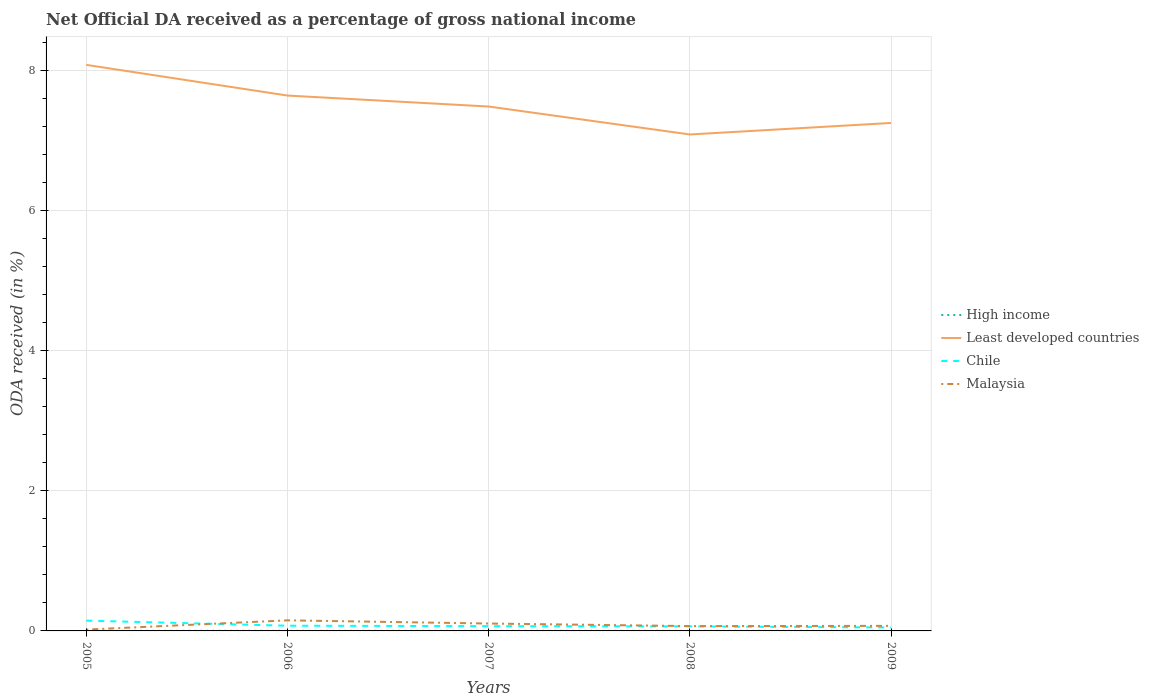How many different coloured lines are there?
Give a very brief answer. 4. Does the line corresponding to High income intersect with the line corresponding to Malaysia?
Offer a terse response. No. Across all years, what is the maximum net official DA received in High income?
Make the answer very short. 0. What is the total net official DA received in Malaysia in the graph?
Offer a very short reply. 0.08. What is the difference between the highest and the second highest net official DA received in High income?
Your answer should be very brief. 0. Is the net official DA received in High income strictly greater than the net official DA received in Malaysia over the years?
Keep it short and to the point. Yes. Are the values on the major ticks of Y-axis written in scientific E-notation?
Your answer should be compact. No. What is the title of the graph?
Provide a succinct answer. Net Official DA received as a percentage of gross national income. What is the label or title of the Y-axis?
Your response must be concise. ODA received (in %). What is the ODA received (in %) in High income in 2005?
Your answer should be very brief. 0. What is the ODA received (in %) in Least developed countries in 2005?
Provide a short and direct response. 8.08. What is the ODA received (in %) of Chile in 2005?
Your response must be concise. 0.15. What is the ODA received (in %) in Malaysia in 2005?
Give a very brief answer. 0.02. What is the ODA received (in %) in High income in 2006?
Provide a short and direct response. 0. What is the ODA received (in %) of Least developed countries in 2006?
Offer a very short reply. 7.64. What is the ODA received (in %) of Chile in 2006?
Your answer should be compact. 0.07. What is the ODA received (in %) of Malaysia in 2006?
Your response must be concise. 0.15. What is the ODA received (in %) in High income in 2007?
Provide a succinct answer. 0. What is the ODA received (in %) of Least developed countries in 2007?
Offer a terse response. 7.49. What is the ODA received (in %) in Chile in 2007?
Keep it short and to the point. 0.07. What is the ODA received (in %) of Malaysia in 2007?
Ensure brevity in your answer.  0.11. What is the ODA received (in %) of High income in 2008?
Provide a succinct answer. 0. What is the ODA received (in %) of Least developed countries in 2008?
Your response must be concise. 7.09. What is the ODA received (in %) in Chile in 2008?
Give a very brief answer. 0.06. What is the ODA received (in %) in Malaysia in 2008?
Give a very brief answer. 0.07. What is the ODA received (in %) of High income in 2009?
Give a very brief answer. 0. What is the ODA received (in %) in Least developed countries in 2009?
Offer a very short reply. 7.25. What is the ODA received (in %) in Chile in 2009?
Make the answer very short. 0.05. What is the ODA received (in %) of Malaysia in 2009?
Ensure brevity in your answer.  0.07. Across all years, what is the maximum ODA received (in %) in High income?
Your answer should be compact. 0. Across all years, what is the maximum ODA received (in %) of Least developed countries?
Offer a very short reply. 8.08. Across all years, what is the maximum ODA received (in %) of Chile?
Keep it short and to the point. 0.15. Across all years, what is the maximum ODA received (in %) in Malaysia?
Give a very brief answer. 0.15. Across all years, what is the minimum ODA received (in %) of High income?
Give a very brief answer. 0. Across all years, what is the minimum ODA received (in %) of Least developed countries?
Your answer should be very brief. 7.09. Across all years, what is the minimum ODA received (in %) in Chile?
Ensure brevity in your answer.  0.05. Across all years, what is the minimum ODA received (in %) in Malaysia?
Your answer should be very brief. 0.02. What is the total ODA received (in %) in High income in the graph?
Offer a very short reply. 0.01. What is the total ODA received (in %) of Least developed countries in the graph?
Your response must be concise. 37.56. What is the total ODA received (in %) of Chile in the graph?
Ensure brevity in your answer.  0.4. What is the total ODA received (in %) of Malaysia in the graph?
Your response must be concise. 0.42. What is the difference between the ODA received (in %) of High income in 2005 and that in 2006?
Give a very brief answer. -0. What is the difference between the ODA received (in %) in Least developed countries in 2005 and that in 2006?
Provide a short and direct response. 0.44. What is the difference between the ODA received (in %) in Chile in 2005 and that in 2006?
Offer a terse response. 0.07. What is the difference between the ODA received (in %) of Malaysia in 2005 and that in 2006?
Provide a short and direct response. -0.13. What is the difference between the ODA received (in %) of High income in 2005 and that in 2007?
Keep it short and to the point. -0. What is the difference between the ODA received (in %) of Least developed countries in 2005 and that in 2007?
Give a very brief answer. 0.59. What is the difference between the ODA received (in %) in Chile in 2005 and that in 2007?
Offer a very short reply. 0.08. What is the difference between the ODA received (in %) in Malaysia in 2005 and that in 2007?
Offer a very short reply. -0.09. What is the difference between the ODA received (in %) of High income in 2005 and that in 2008?
Your answer should be compact. -0. What is the difference between the ODA received (in %) in Least developed countries in 2005 and that in 2008?
Your answer should be very brief. 0.99. What is the difference between the ODA received (in %) of Chile in 2005 and that in 2008?
Your answer should be very brief. 0.08. What is the difference between the ODA received (in %) of Malaysia in 2005 and that in 2008?
Keep it short and to the point. -0.05. What is the difference between the ODA received (in %) of High income in 2005 and that in 2009?
Offer a very short reply. -0. What is the difference between the ODA received (in %) of Least developed countries in 2005 and that in 2009?
Ensure brevity in your answer.  0.83. What is the difference between the ODA received (in %) of Chile in 2005 and that in 2009?
Your answer should be very brief. 0.1. What is the difference between the ODA received (in %) of Malaysia in 2005 and that in 2009?
Offer a very short reply. -0.05. What is the difference between the ODA received (in %) of High income in 2006 and that in 2007?
Your answer should be compact. 0. What is the difference between the ODA received (in %) in Least developed countries in 2006 and that in 2007?
Provide a short and direct response. 0.16. What is the difference between the ODA received (in %) in Chile in 2006 and that in 2007?
Provide a short and direct response. 0.01. What is the difference between the ODA received (in %) of Malaysia in 2006 and that in 2007?
Provide a succinct answer. 0.05. What is the difference between the ODA received (in %) in High income in 2006 and that in 2008?
Your answer should be compact. -0. What is the difference between the ODA received (in %) of Least developed countries in 2006 and that in 2008?
Give a very brief answer. 0.56. What is the difference between the ODA received (in %) in Chile in 2006 and that in 2008?
Offer a very short reply. 0.01. What is the difference between the ODA received (in %) in Malaysia in 2006 and that in 2008?
Provide a short and direct response. 0.08. What is the difference between the ODA received (in %) of Least developed countries in 2006 and that in 2009?
Make the answer very short. 0.39. What is the difference between the ODA received (in %) in Chile in 2006 and that in 2009?
Provide a short and direct response. 0.03. What is the difference between the ODA received (in %) in Malaysia in 2006 and that in 2009?
Offer a very short reply. 0.08. What is the difference between the ODA received (in %) in High income in 2007 and that in 2008?
Give a very brief answer. -0. What is the difference between the ODA received (in %) of Least developed countries in 2007 and that in 2008?
Give a very brief answer. 0.4. What is the difference between the ODA received (in %) of Chile in 2007 and that in 2008?
Ensure brevity in your answer.  0. What is the difference between the ODA received (in %) of Malaysia in 2007 and that in 2008?
Give a very brief answer. 0.04. What is the difference between the ODA received (in %) in Least developed countries in 2007 and that in 2009?
Provide a short and direct response. 0.23. What is the difference between the ODA received (in %) in Chile in 2007 and that in 2009?
Your answer should be compact. 0.02. What is the difference between the ODA received (in %) in Malaysia in 2007 and that in 2009?
Ensure brevity in your answer.  0.03. What is the difference between the ODA received (in %) in Least developed countries in 2008 and that in 2009?
Ensure brevity in your answer.  -0.16. What is the difference between the ODA received (in %) of Chile in 2008 and that in 2009?
Your answer should be very brief. 0.02. What is the difference between the ODA received (in %) of Malaysia in 2008 and that in 2009?
Offer a very short reply. -0. What is the difference between the ODA received (in %) in High income in 2005 and the ODA received (in %) in Least developed countries in 2006?
Your answer should be very brief. -7.64. What is the difference between the ODA received (in %) in High income in 2005 and the ODA received (in %) in Chile in 2006?
Your answer should be very brief. -0.07. What is the difference between the ODA received (in %) in High income in 2005 and the ODA received (in %) in Malaysia in 2006?
Offer a terse response. -0.15. What is the difference between the ODA received (in %) of Least developed countries in 2005 and the ODA received (in %) of Chile in 2006?
Your answer should be compact. 8.01. What is the difference between the ODA received (in %) in Least developed countries in 2005 and the ODA received (in %) in Malaysia in 2006?
Give a very brief answer. 7.93. What is the difference between the ODA received (in %) in Chile in 2005 and the ODA received (in %) in Malaysia in 2006?
Provide a short and direct response. -0. What is the difference between the ODA received (in %) in High income in 2005 and the ODA received (in %) in Least developed countries in 2007?
Offer a very short reply. -7.49. What is the difference between the ODA received (in %) in High income in 2005 and the ODA received (in %) in Chile in 2007?
Your answer should be compact. -0.07. What is the difference between the ODA received (in %) in High income in 2005 and the ODA received (in %) in Malaysia in 2007?
Provide a short and direct response. -0.1. What is the difference between the ODA received (in %) in Least developed countries in 2005 and the ODA received (in %) in Chile in 2007?
Make the answer very short. 8.01. What is the difference between the ODA received (in %) of Least developed countries in 2005 and the ODA received (in %) of Malaysia in 2007?
Provide a short and direct response. 7.98. What is the difference between the ODA received (in %) in Chile in 2005 and the ODA received (in %) in Malaysia in 2007?
Offer a terse response. 0.04. What is the difference between the ODA received (in %) in High income in 2005 and the ODA received (in %) in Least developed countries in 2008?
Make the answer very short. -7.09. What is the difference between the ODA received (in %) of High income in 2005 and the ODA received (in %) of Chile in 2008?
Keep it short and to the point. -0.06. What is the difference between the ODA received (in %) in High income in 2005 and the ODA received (in %) in Malaysia in 2008?
Keep it short and to the point. -0.07. What is the difference between the ODA received (in %) of Least developed countries in 2005 and the ODA received (in %) of Chile in 2008?
Keep it short and to the point. 8.02. What is the difference between the ODA received (in %) of Least developed countries in 2005 and the ODA received (in %) of Malaysia in 2008?
Provide a short and direct response. 8.01. What is the difference between the ODA received (in %) of Chile in 2005 and the ODA received (in %) of Malaysia in 2008?
Make the answer very short. 0.08. What is the difference between the ODA received (in %) of High income in 2005 and the ODA received (in %) of Least developed countries in 2009?
Provide a succinct answer. -7.25. What is the difference between the ODA received (in %) in High income in 2005 and the ODA received (in %) in Chile in 2009?
Keep it short and to the point. -0.05. What is the difference between the ODA received (in %) in High income in 2005 and the ODA received (in %) in Malaysia in 2009?
Offer a terse response. -0.07. What is the difference between the ODA received (in %) of Least developed countries in 2005 and the ODA received (in %) of Chile in 2009?
Provide a short and direct response. 8.03. What is the difference between the ODA received (in %) of Least developed countries in 2005 and the ODA received (in %) of Malaysia in 2009?
Your answer should be very brief. 8.01. What is the difference between the ODA received (in %) in Chile in 2005 and the ODA received (in %) in Malaysia in 2009?
Keep it short and to the point. 0.07. What is the difference between the ODA received (in %) of High income in 2006 and the ODA received (in %) of Least developed countries in 2007?
Your answer should be compact. -7.49. What is the difference between the ODA received (in %) of High income in 2006 and the ODA received (in %) of Chile in 2007?
Your answer should be compact. -0.07. What is the difference between the ODA received (in %) in High income in 2006 and the ODA received (in %) in Malaysia in 2007?
Your answer should be very brief. -0.1. What is the difference between the ODA received (in %) of Least developed countries in 2006 and the ODA received (in %) of Chile in 2007?
Your response must be concise. 7.58. What is the difference between the ODA received (in %) in Least developed countries in 2006 and the ODA received (in %) in Malaysia in 2007?
Your answer should be very brief. 7.54. What is the difference between the ODA received (in %) in Chile in 2006 and the ODA received (in %) in Malaysia in 2007?
Provide a succinct answer. -0.03. What is the difference between the ODA received (in %) of High income in 2006 and the ODA received (in %) of Least developed countries in 2008?
Offer a terse response. -7.09. What is the difference between the ODA received (in %) of High income in 2006 and the ODA received (in %) of Chile in 2008?
Make the answer very short. -0.06. What is the difference between the ODA received (in %) of High income in 2006 and the ODA received (in %) of Malaysia in 2008?
Your answer should be compact. -0.07. What is the difference between the ODA received (in %) of Least developed countries in 2006 and the ODA received (in %) of Chile in 2008?
Keep it short and to the point. 7.58. What is the difference between the ODA received (in %) of Least developed countries in 2006 and the ODA received (in %) of Malaysia in 2008?
Make the answer very short. 7.58. What is the difference between the ODA received (in %) in Chile in 2006 and the ODA received (in %) in Malaysia in 2008?
Your response must be concise. 0.01. What is the difference between the ODA received (in %) of High income in 2006 and the ODA received (in %) of Least developed countries in 2009?
Your answer should be compact. -7.25. What is the difference between the ODA received (in %) in High income in 2006 and the ODA received (in %) in Chile in 2009?
Make the answer very short. -0.05. What is the difference between the ODA received (in %) in High income in 2006 and the ODA received (in %) in Malaysia in 2009?
Keep it short and to the point. -0.07. What is the difference between the ODA received (in %) of Least developed countries in 2006 and the ODA received (in %) of Chile in 2009?
Make the answer very short. 7.6. What is the difference between the ODA received (in %) of Least developed countries in 2006 and the ODA received (in %) of Malaysia in 2009?
Provide a succinct answer. 7.57. What is the difference between the ODA received (in %) in Chile in 2006 and the ODA received (in %) in Malaysia in 2009?
Your response must be concise. 0. What is the difference between the ODA received (in %) of High income in 2007 and the ODA received (in %) of Least developed countries in 2008?
Provide a succinct answer. -7.09. What is the difference between the ODA received (in %) of High income in 2007 and the ODA received (in %) of Chile in 2008?
Keep it short and to the point. -0.06. What is the difference between the ODA received (in %) in High income in 2007 and the ODA received (in %) in Malaysia in 2008?
Your response must be concise. -0.07. What is the difference between the ODA received (in %) in Least developed countries in 2007 and the ODA received (in %) in Chile in 2008?
Provide a succinct answer. 7.42. What is the difference between the ODA received (in %) of Least developed countries in 2007 and the ODA received (in %) of Malaysia in 2008?
Your answer should be compact. 7.42. What is the difference between the ODA received (in %) of Chile in 2007 and the ODA received (in %) of Malaysia in 2008?
Offer a very short reply. -0. What is the difference between the ODA received (in %) in High income in 2007 and the ODA received (in %) in Least developed countries in 2009?
Offer a very short reply. -7.25. What is the difference between the ODA received (in %) of High income in 2007 and the ODA received (in %) of Chile in 2009?
Give a very brief answer. -0.05. What is the difference between the ODA received (in %) in High income in 2007 and the ODA received (in %) in Malaysia in 2009?
Make the answer very short. -0.07. What is the difference between the ODA received (in %) of Least developed countries in 2007 and the ODA received (in %) of Chile in 2009?
Offer a terse response. 7.44. What is the difference between the ODA received (in %) of Least developed countries in 2007 and the ODA received (in %) of Malaysia in 2009?
Keep it short and to the point. 7.42. What is the difference between the ODA received (in %) in Chile in 2007 and the ODA received (in %) in Malaysia in 2009?
Provide a short and direct response. -0. What is the difference between the ODA received (in %) of High income in 2008 and the ODA received (in %) of Least developed countries in 2009?
Offer a terse response. -7.25. What is the difference between the ODA received (in %) in High income in 2008 and the ODA received (in %) in Chile in 2009?
Offer a terse response. -0.05. What is the difference between the ODA received (in %) of High income in 2008 and the ODA received (in %) of Malaysia in 2009?
Provide a short and direct response. -0.07. What is the difference between the ODA received (in %) of Least developed countries in 2008 and the ODA received (in %) of Chile in 2009?
Give a very brief answer. 7.04. What is the difference between the ODA received (in %) of Least developed countries in 2008 and the ODA received (in %) of Malaysia in 2009?
Your answer should be compact. 7.02. What is the difference between the ODA received (in %) of Chile in 2008 and the ODA received (in %) of Malaysia in 2009?
Ensure brevity in your answer.  -0.01. What is the average ODA received (in %) in High income per year?
Offer a very short reply. 0. What is the average ODA received (in %) in Least developed countries per year?
Give a very brief answer. 7.51. What is the average ODA received (in %) of Chile per year?
Provide a short and direct response. 0.08. What is the average ODA received (in %) of Malaysia per year?
Provide a succinct answer. 0.08. In the year 2005, what is the difference between the ODA received (in %) in High income and ODA received (in %) in Least developed countries?
Make the answer very short. -8.08. In the year 2005, what is the difference between the ODA received (in %) of High income and ODA received (in %) of Chile?
Provide a succinct answer. -0.15. In the year 2005, what is the difference between the ODA received (in %) of High income and ODA received (in %) of Malaysia?
Provide a short and direct response. -0.02. In the year 2005, what is the difference between the ODA received (in %) of Least developed countries and ODA received (in %) of Chile?
Ensure brevity in your answer.  7.94. In the year 2005, what is the difference between the ODA received (in %) in Least developed countries and ODA received (in %) in Malaysia?
Provide a succinct answer. 8.06. In the year 2005, what is the difference between the ODA received (in %) of Chile and ODA received (in %) of Malaysia?
Provide a succinct answer. 0.13. In the year 2006, what is the difference between the ODA received (in %) of High income and ODA received (in %) of Least developed countries?
Offer a very short reply. -7.64. In the year 2006, what is the difference between the ODA received (in %) in High income and ODA received (in %) in Chile?
Offer a terse response. -0.07. In the year 2006, what is the difference between the ODA received (in %) in Least developed countries and ODA received (in %) in Chile?
Provide a succinct answer. 7.57. In the year 2006, what is the difference between the ODA received (in %) in Least developed countries and ODA received (in %) in Malaysia?
Keep it short and to the point. 7.49. In the year 2006, what is the difference between the ODA received (in %) of Chile and ODA received (in %) of Malaysia?
Your answer should be very brief. -0.08. In the year 2007, what is the difference between the ODA received (in %) in High income and ODA received (in %) in Least developed countries?
Provide a succinct answer. -7.49. In the year 2007, what is the difference between the ODA received (in %) of High income and ODA received (in %) of Chile?
Provide a succinct answer. -0.07. In the year 2007, what is the difference between the ODA received (in %) in High income and ODA received (in %) in Malaysia?
Your answer should be compact. -0.1. In the year 2007, what is the difference between the ODA received (in %) of Least developed countries and ODA received (in %) of Chile?
Provide a short and direct response. 7.42. In the year 2007, what is the difference between the ODA received (in %) in Least developed countries and ODA received (in %) in Malaysia?
Your answer should be very brief. 7.38. In the year 2007, what is the difference between the ODA received (in %) in Chile and ODA received (in %) in Malaysia?
Your answer should be very brief. -0.04. In the year 2008, what is the difference between the ODA received (in %) of High income and ODA received (in %) of Least developed countries?
Keep it short and to the point. -7.09. In the year 2008, what is the difference between the ODA received (in %) in High income and ODA received (in %) in Chile?
Ensure brevity in your answer.  -0.06. In the year 2008, what is the difference between the ODA received (in %) in High income and ODA received (in %) in Malaysia?
Offer a very short reply. -0.07. In the year 2008, what is the difference between the ODA received (in %) in Least developed countries and ODA received (in %) in Chile?
Your answer should be compact. 7.02. In the year 2008, what is the difference between the ODA received (in %) in Least developed countries and ODA received (in %) in Malaysia?
Your response must be concise. 7.02. In the year 2008, what is the difference between the ODA received (in %) in Chile and ODA received (in %) in Malaysia?
Offer a very short reply. -0. In the year 2009, what is the difference between the ODA received (in %) of High income and ODA received (in %) of Least developed countries?
Your response must be concise. -7.25. In the year 2009, what is the difference between the ODA received (in %) of High income and ODA received (in %) of Chile?
Your answer should be compact. -0.05. In the year 2009, what is the difference between the ODA received (in %) of High income and ODA received (in %) of Malaysia?
Your answer should be compact. -0.07. In the year 2009, what is the difference between the ODA received (in %) in Least developed countries and ODA received (in %) in Chile?
Ensure brevity in your answer.  7.2. In the year 2009, what is the difference between the ODA received (in %) of Least developed countries and ODA received (in %) of Malaysia?
Ensure brevity in your answer.  7.18. In the year 2009, what is the difference between the ODA received (in %) of Chile and ODA received (in %) of Malaysia?
Your response must be concise. -0.02. What is the ratio of the ODA received (in %) of High income in 2005 to that in 2006?
Your response must be concise. 0.95. What is the ratio of the ODA received (in %) in Least developed countries in 2005 to that in 2006?
Provide a succinct answer. 1.06. What is the ratio of the ODA received (in %) of Chile in 2005 to that in 2006?
Give a very brief answer. 1.97. What is the ratio of the ODA received (in %) of Malaysia in 2005 to that in 2006?
Make the answer very short. 0.13. What is the ratio of the ODA received (in %) of Least developed countries in 2005 to that in 2007?
Give a very brief answer. 1.08. What is the ratio of the ODA received (in %) in Chile in 2005 to that in 2007?
Your response must be concise. 2.16. What is the ratio of the ODA received (in %) of Malaysia in 2005 to that in 2007?
Offer a very short reply. 0.18. What is the ratio of the ODA received (in %) of High income in 2005 to that in 2008?
Keep it short and to the point. 0.89. What is the ratio of the ODA received (in %) of Least developed countries in 2005 to that in 2008?
Offer a terse response. 1.14. What is the ratio of the ODA received (in %) in Chile in 2005 to that in 2008?
Provide a succinct answer. 2.27. What is the ratio of the ODA received (in %) of Malaysia in 2005 to that in 2008?
Your answer should be compact. 0.28. What is the ratio of the ODA received (in %) of High income in 2005 to that in 2009?
Your response must be concise. 0.93. What is the ratio of the ODA received (in %) of Least developed countries in 2005 to that in 2009?
Give a very brief answer. 1.11. What is the ratio of the ODA received (in %) of Chile in 2005 to that in 2009?
Ensure brevity in your answer.  3. What is the ratio of the ODA received (in %) in Malaysia in 2005 to that in 2009?
Provide a succinct answer. 0.26. What is the ratio of the ODA received (in %) in High income in 2006 to that in 2007?
Keep it short and to the point. 1.02. What is the ratio of the ODA received (in %) in Least developed countries in 2006 to that in 2007?
Keep it short and to the point. 1.02. What is the ratio of the ODA received (in %) of Chile in 2006 to that in 2007?
Your answer should be very brief. 1.1. What is the ratio of the ODA received (in %) of Malaysia in 2006 to that in 2007?
Ensure brevity in your answer.  1.43. What is the ratio of the ODA received (in %) in High income in 2006 to that in 2008?
Keep it short and to the point. 0.94. What is the ratio of the ODA received (in %) of Least developed countries in 2006 to that in 2008?
Offer a terse response. 1.08. What is the ratio of the ODA received (in %) of Chile in 2006 to that in 2008?
Your answer should be very brief. 1.15. What is the ratio of the ODA received (in %) of Malaysia in 2006 to that in 2008?
Ensure brevity in your answer.  2.19. What is the ratio of the ODA received (in %) in High income in 2006 to that in 2009?
Make the answer very short. 0.98. What is the ratio of the ODA received (in %) of Least developed countries in 2006 to that in 2009?
Keep it short and to the point. 1.05. What is the ratio of the ODA received (in %) of Chile in 2006 to that in 2009?
Your response must be concise. 1.52. What is the ratio of the ODA received (in %) of Malaysia in 2006 to that in 2009?
Offer a terse response. 2.1. What is the ratio of the ODA received (in %) in High income in 2007 to that in 2008?
Provide a succinct answer. 0.92. What is the ratio of the ODA received (in %) in Least developed countries in 2007 to that in 2008?
Your answer should be very brief. 1.06. What is the ratio of the ODA received (in %) in Chile in 2007 to that in 2008?
Provide a succinct answer. 1.05. What is the ratio of the ODA received (in %) of Malaysia in 2007 to that in 2008?
Keep it short and to the point. 1.53. What is the ratio of the ODA received (in %) of High income in 2007 to that in 2009?
Your response must be concise. 0.96. What is the ratio of the ODA received (in %) in Least developed countries in 2007 to that in 2009?
Keep it short and to the point. 1.03. What is the ratio of the ODA received (in %) in Chile in 2007 to that in 2009?
Provide a succinct answer. 1.39. What is the ratio of the ODA received (in %) in Malaysia in 2007 to that in 2009?
Keep it short and to the point. 1.46. What is the ratio of the ODA received (in %) of High income in 2008 to that in 2009?
Keep it short and to the point. 1.04. What is the ratio of the ODA received (in %) of Least developed countries in 2008 to that in 2009?
Your answer should be very brief. 0.98. What is the ratio of the ODA received (in %) of Chile in 2008 to that in 2009?
Ensure brevity in your answer.  1.32. What is the ratio of the ODA received (in %) in Malaysia in 2008 to that in 2009?
Your response must be concise. 0.96. What is the difference between the highest and the second highest ODA received (in %) of Least developed countries?
Give a very brief answer. 0.44. What is the difference between the highest and the second highest ODA received (in %) in Chile?
Make the answer very short. 0.07. What is the difference between the highest and the second highest ODA received (in %) of Malaysia?
Your answer should be very brief. 0.05. What is the difference between the highest and the lowest ODA received (in %) of High income?
Your answer should be compact. 0. What is the difference between the highest and the lowest ODA received (in %) of Chile?
Ensure brevity in your answer.  0.1. What is the difference between the highest and the lowest ODA received (in %) of Malaysia?
Make the answer very short. 0.13. 